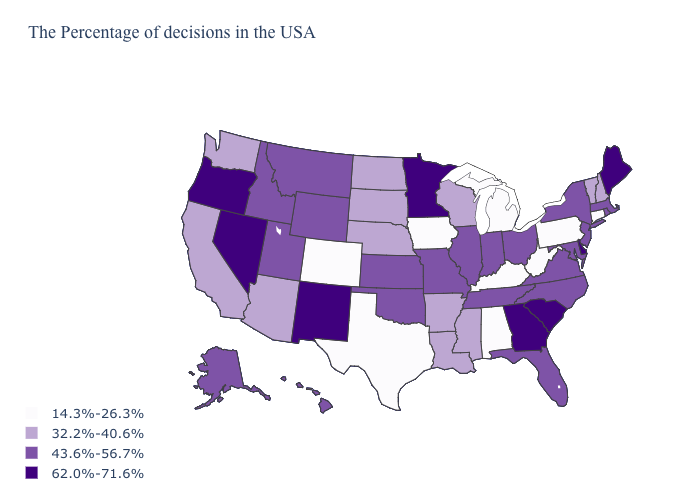What is the highest value in the USA?
Short answer required. 62.0%-71.6%. Does New York have the same value as Connecticut?
Short answer required. No. How many symbols are there in the legend?
Concise answer only. 4. What is the highest value in states that border Arkansas?
Quick response, please. 43.6%-56.7%. How many symbols are there in the legend?
Quick response, please. 4. What is the value of South Carolina?
Answer briefly. 62.0%-71.6%. Name the states that have a value in the range 62.0%-71.6%?
Short answer required. Maine, Delaware, South Carolina, Georgia, Minnesota, New Mexico, Nevada, Oregon. Name the states that have a value in the range 14.3%-26.3%?
Give a very brief answer. Connecticut, Pennsylvania, West Virginia, Michigan, Kentucky, Alabama, Iowa, Texas, Colorado. Name the states that have a value in the range 14.3%-26.3%?
Give a very brief answer. Connecticut, Pennsylvania, West Virginia, Michigan, Kentucky, Alabama, Iowa, Texas, Colorado. Does Ohio have the same value as Idaho?
Write a very short answer. Yes. Which states hav the highest value in the MidWest?
Be succinct. Minnesota. Does Connecticut have a higher value than New York?
Give a very brief answer. No. What is the value of Mississippi?
Write a very short answer. 32.2%-40.6%. Does Wyoming have a higher value than Oregon?
Quick response, please. No. Does Tennessee have the lowest value in the South?
Keep it brief. No. 